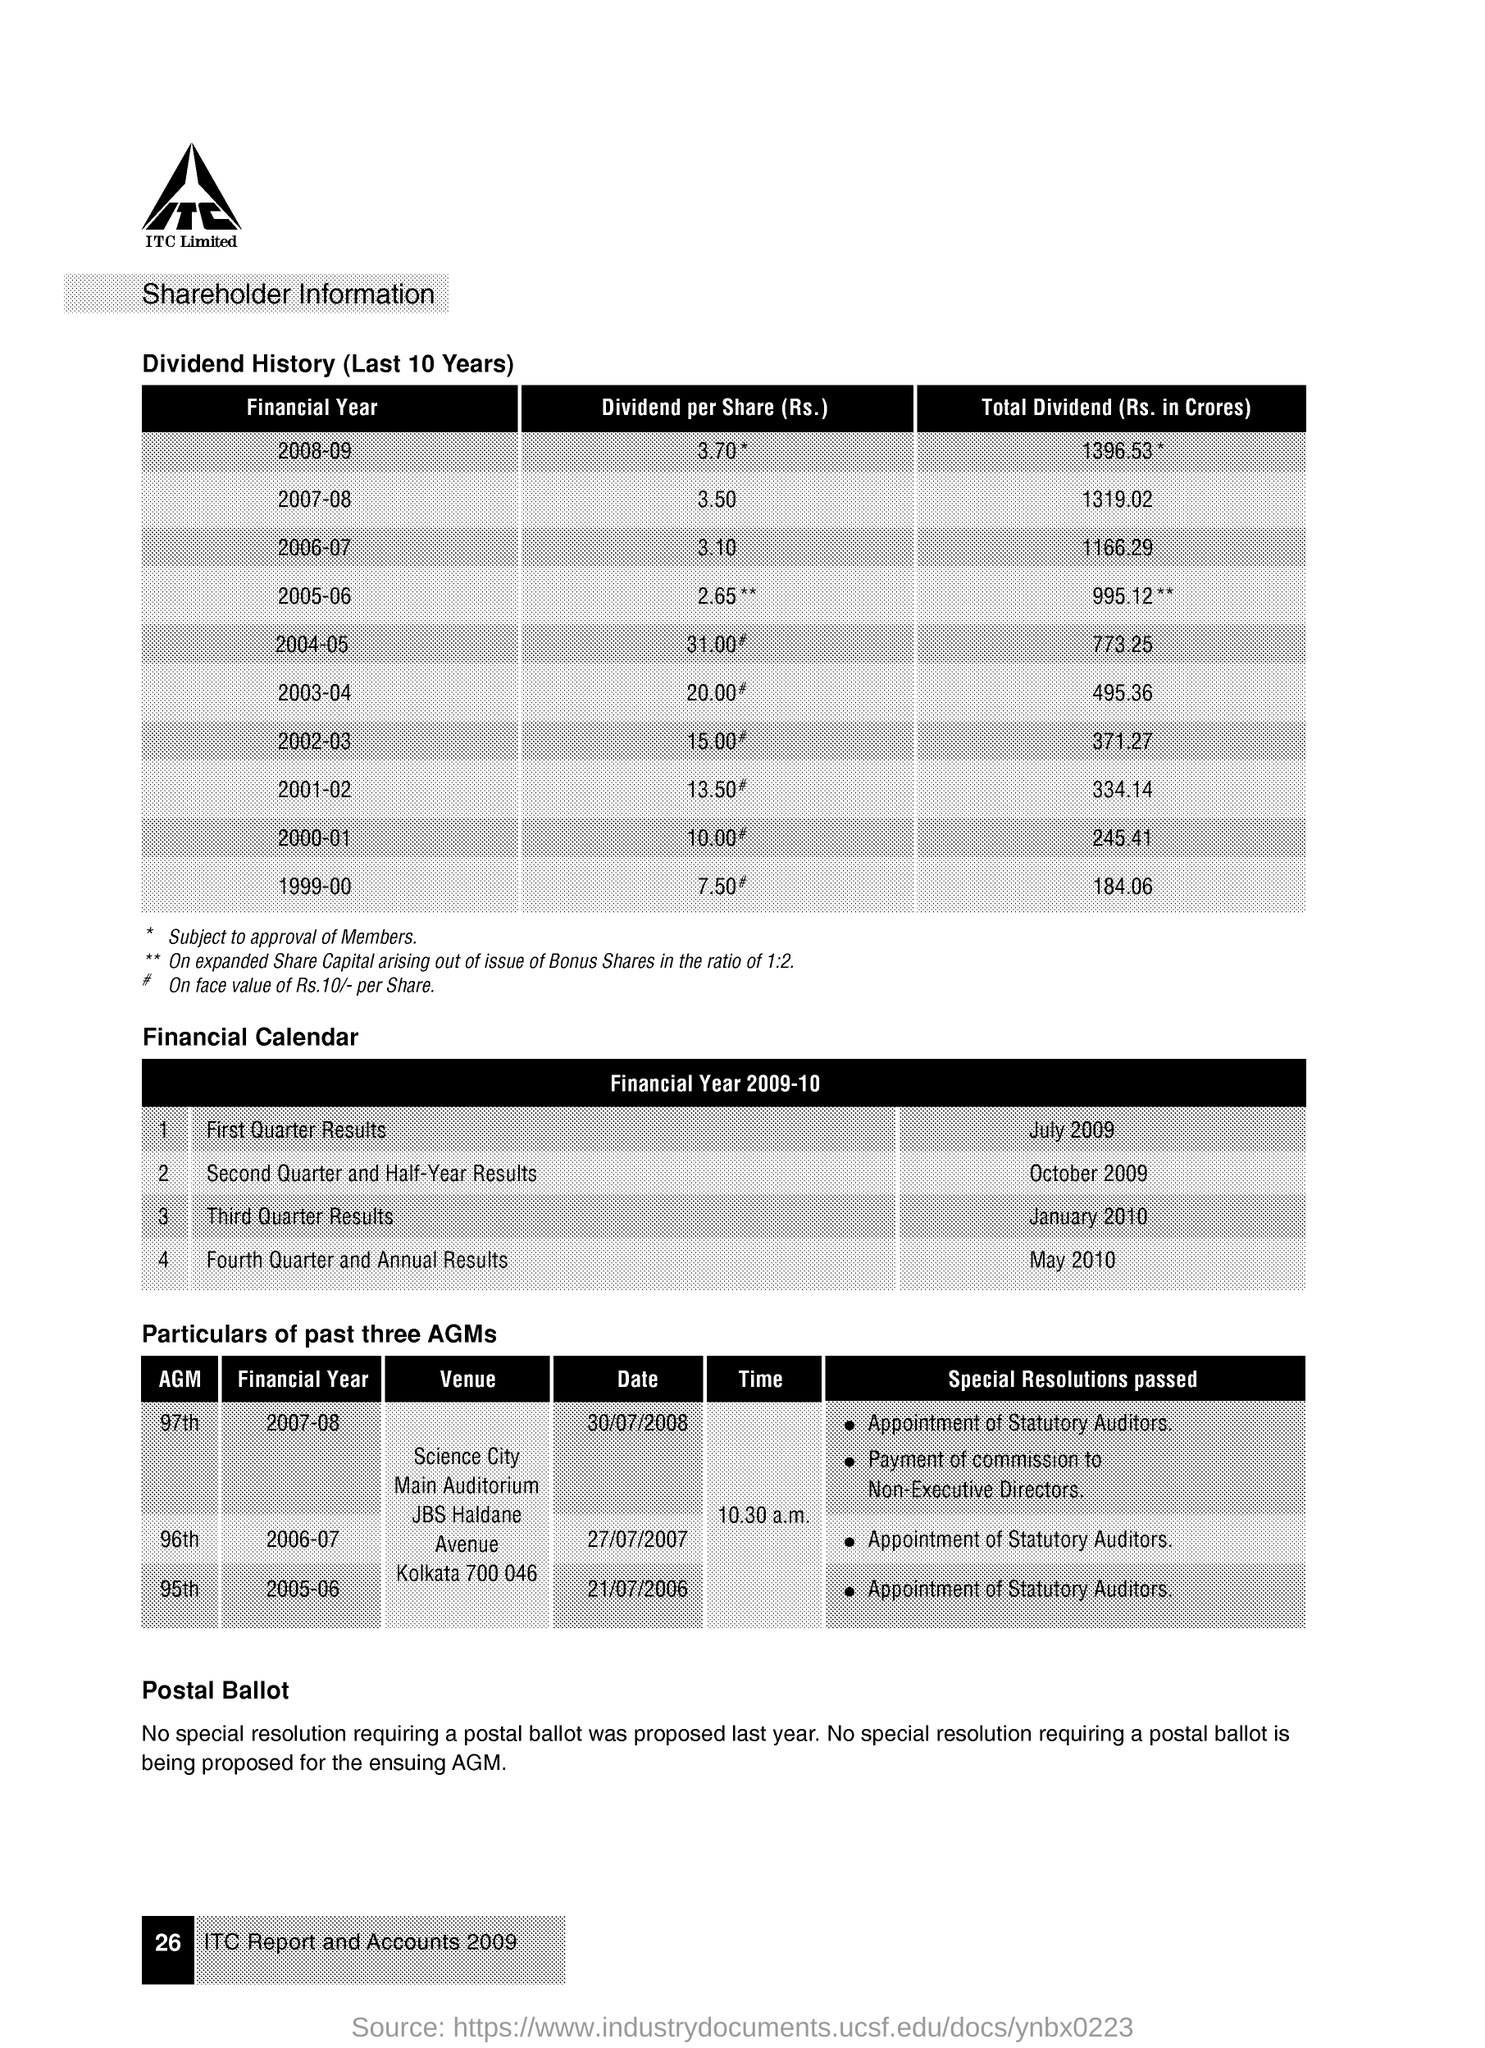Can you tell me the venue where the 95th AGM was held? The 95th AGM was held at Kolkata 700 046, as mentioned in the document in the image. 